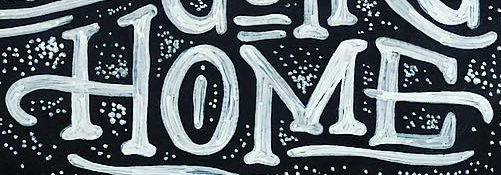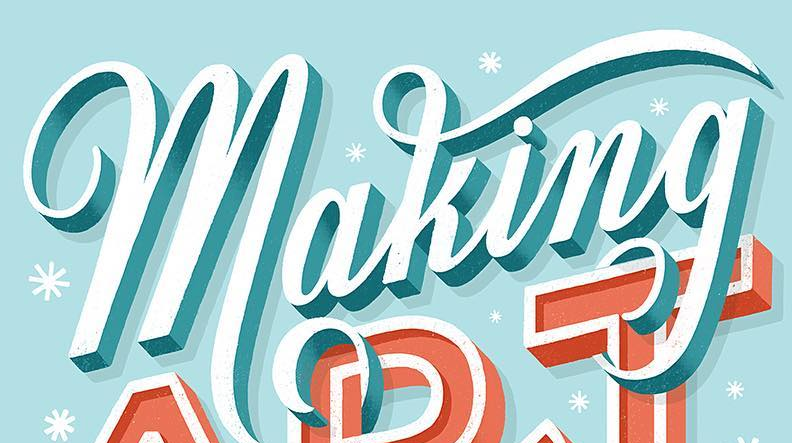What words can you see in these images in sequence, separated by a semicolon? HOME; making 